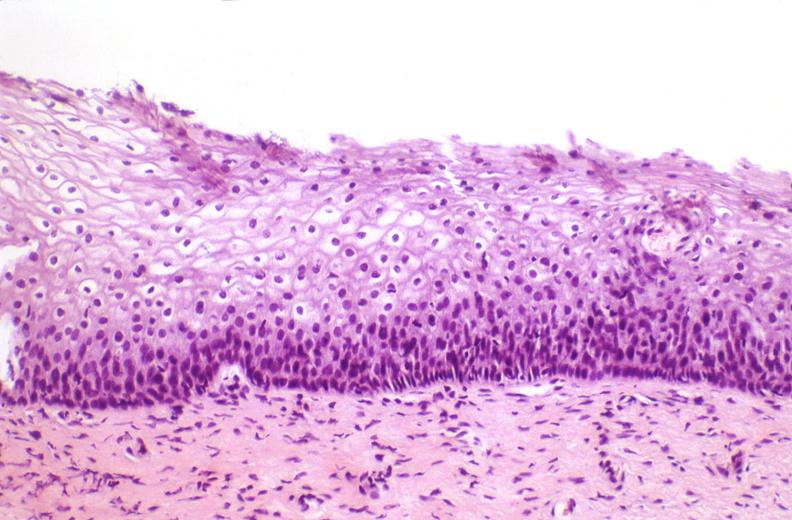what is present?
Answer the question using a single word or phrase. Female reproductive 